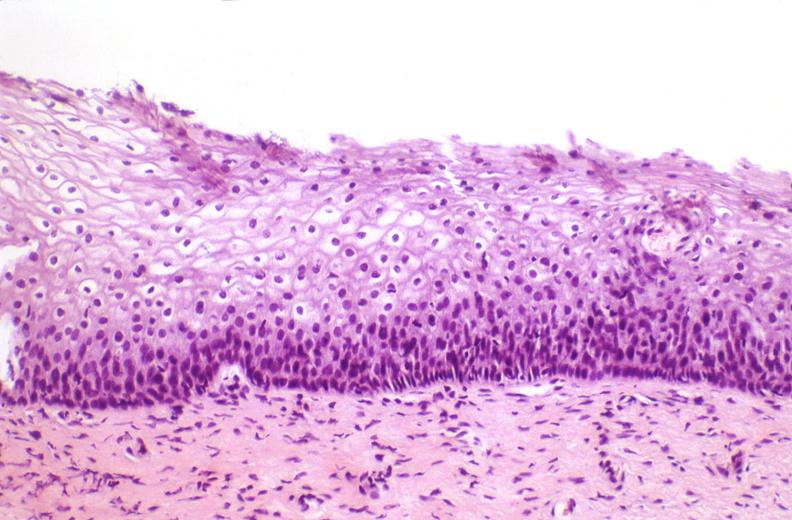what is present?
Answer the question using a single word or phrase. Female reproductive 